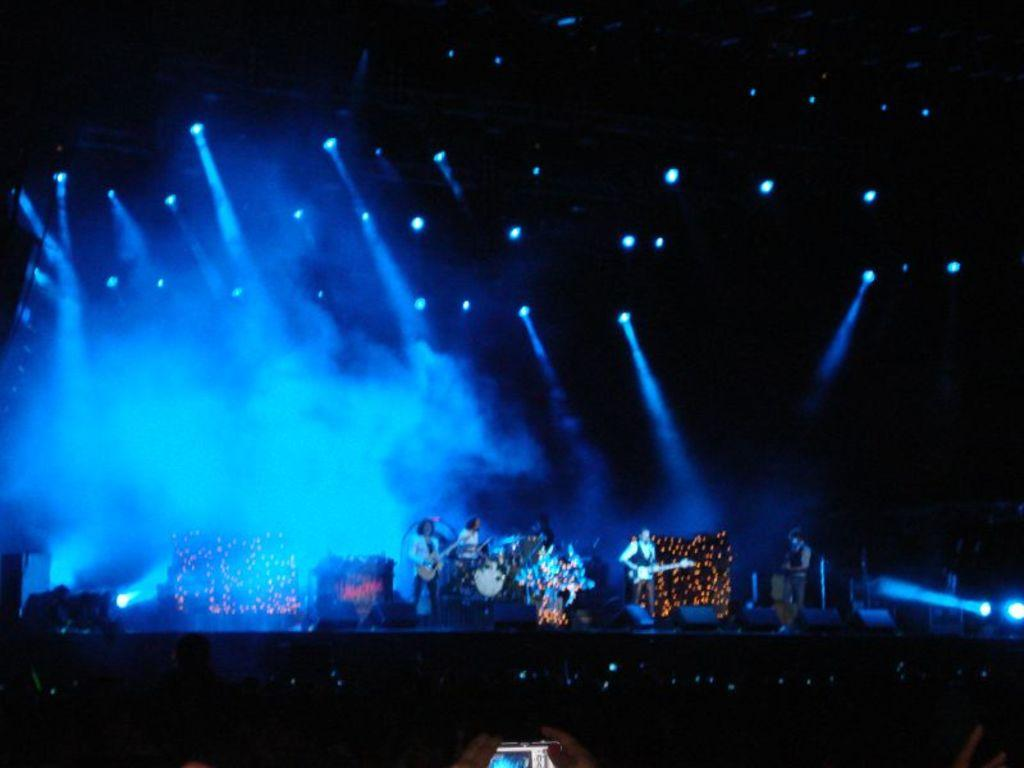What is happening on the stage in the image? There are people performing on a stage in the image. What can be seen above the stage in the image? There are lights visible at the top of the image. Who or what is in the foreground of the image? There are people in the foreground of the image. Can you identify any object in the image that is commonly used for communication? Yes, there is a phone in the image. What type of toothbrush is being used by the performers on stage? There is no toothbrush present in the image; it is a performance on a stage with lights and people in the foreground. 